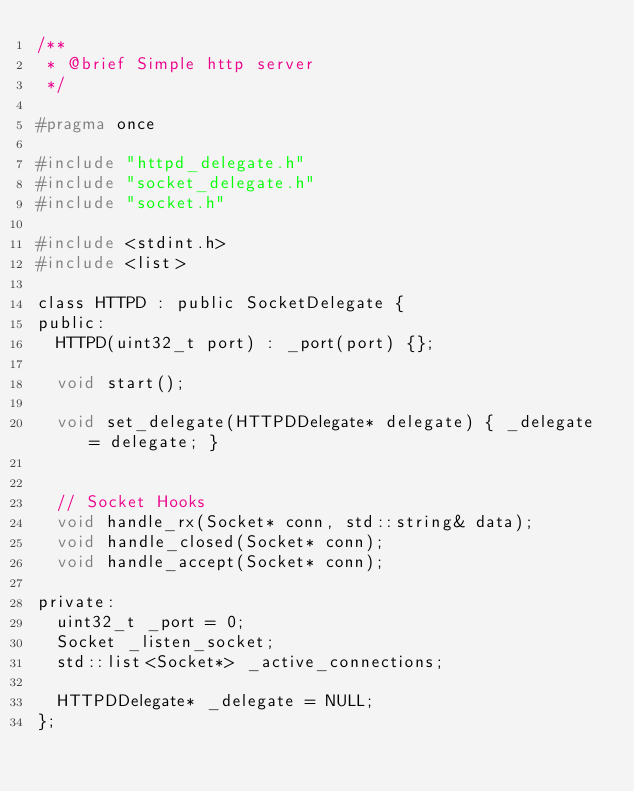Convert code to text. <code><loc_0><loc_0><loc_500><loc_500><_C_>/**
 * @brief Simple http server
 */

#pragma once

#include "httpd_delegate.h"
#include "socket_delegate.h"
#include "socket.h"

#include <stdint.h>
#include <list>

class HTTPD : public SocketDelegate {
public:
  HTTPD(uint32_t port) : _port(port) {};

  void start();

  void set_delegate(HTTPDDelegate* delegate) { _delegate = delegate; }


  // Socket Hooks
  void handle_rx(Socket* conn, std::string& data);
  void handle_closed(Socket* conn);
  void handle_accept(Socket* conn);

private:
  uint32_t _port = 0;
  Socket _listen_socket;
  std::list<Socket*> _active_connections;

  HTTPDDelegate* _delegate = NULL;
};
</code> 